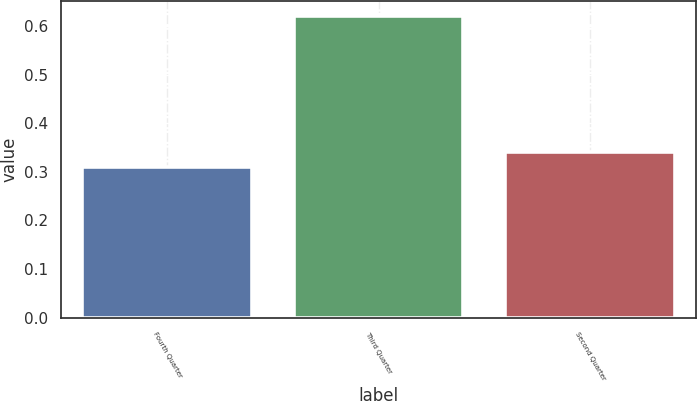Convert chart to OTSL. <chart><loc_0><loc_0><loc_500><loc_500><bar_chart><fcel>Fourth Quarter<fcel>Third Quarter<fcel>Second Quarter<nl><fcel>0.31<fcel>0.62<fcel>0.34<nl></chart> 